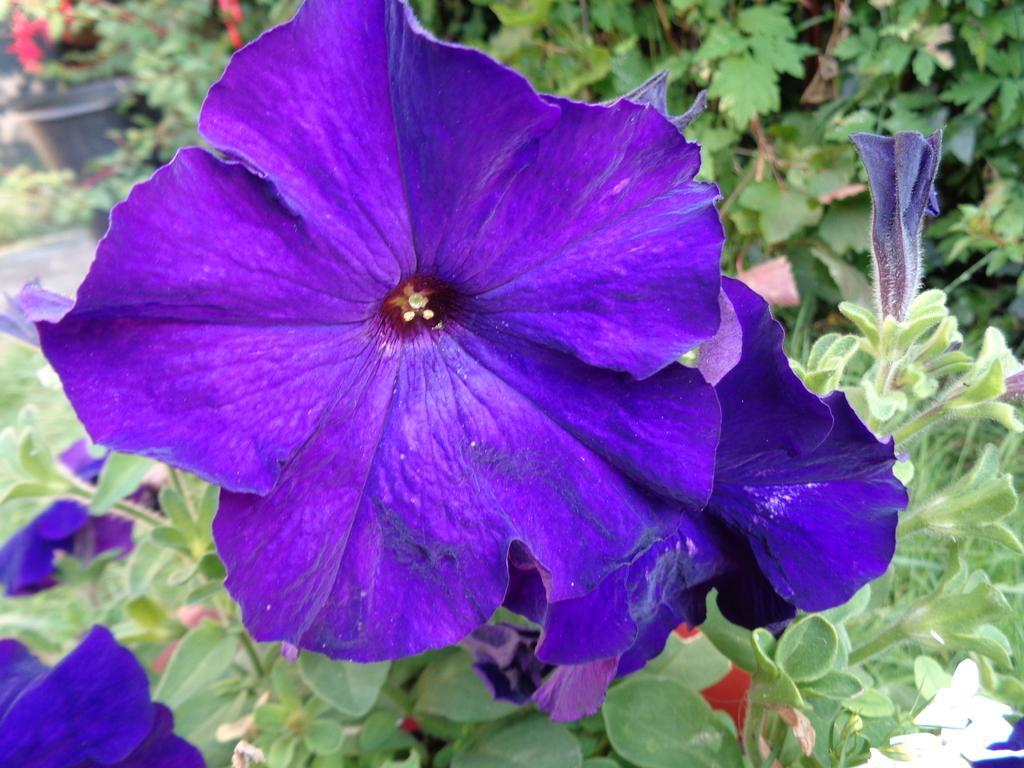Describe this image in one or two sentences. In this image there are flowers and plants. 